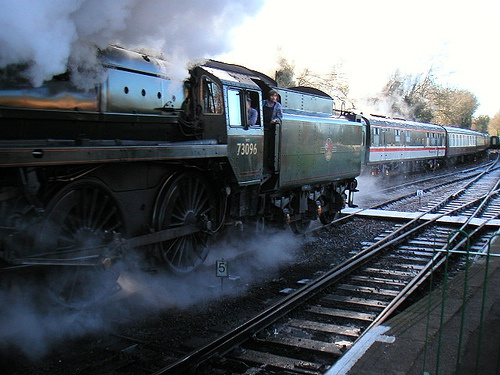Describe the objects in this image and their specific colors. I can see train in darkgray, black, gray, navy, and blue tones, people in darkgray, black, gray, and navy tones, and people in darkgray, gray, navy, and black tones in this image. 